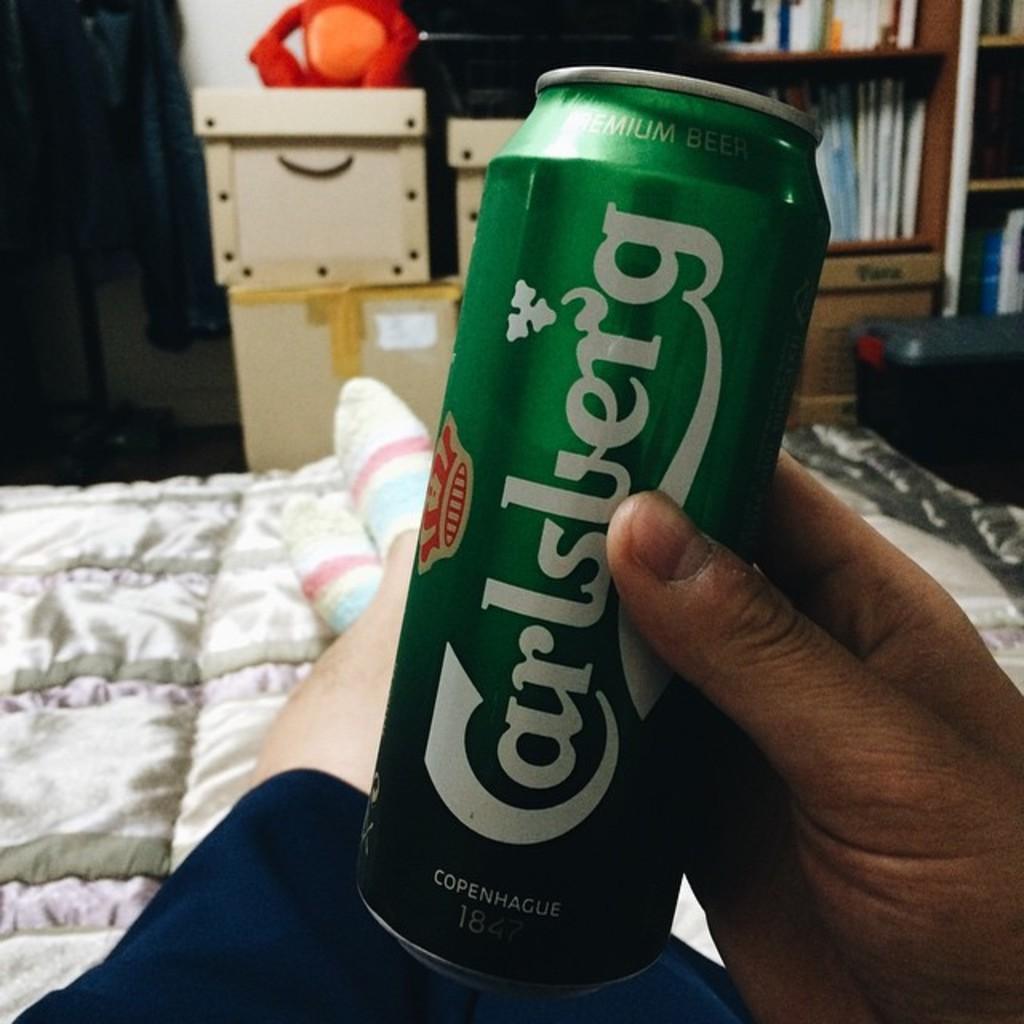What brand is the beverage?
Offer a very short reply. Carlsberg. 